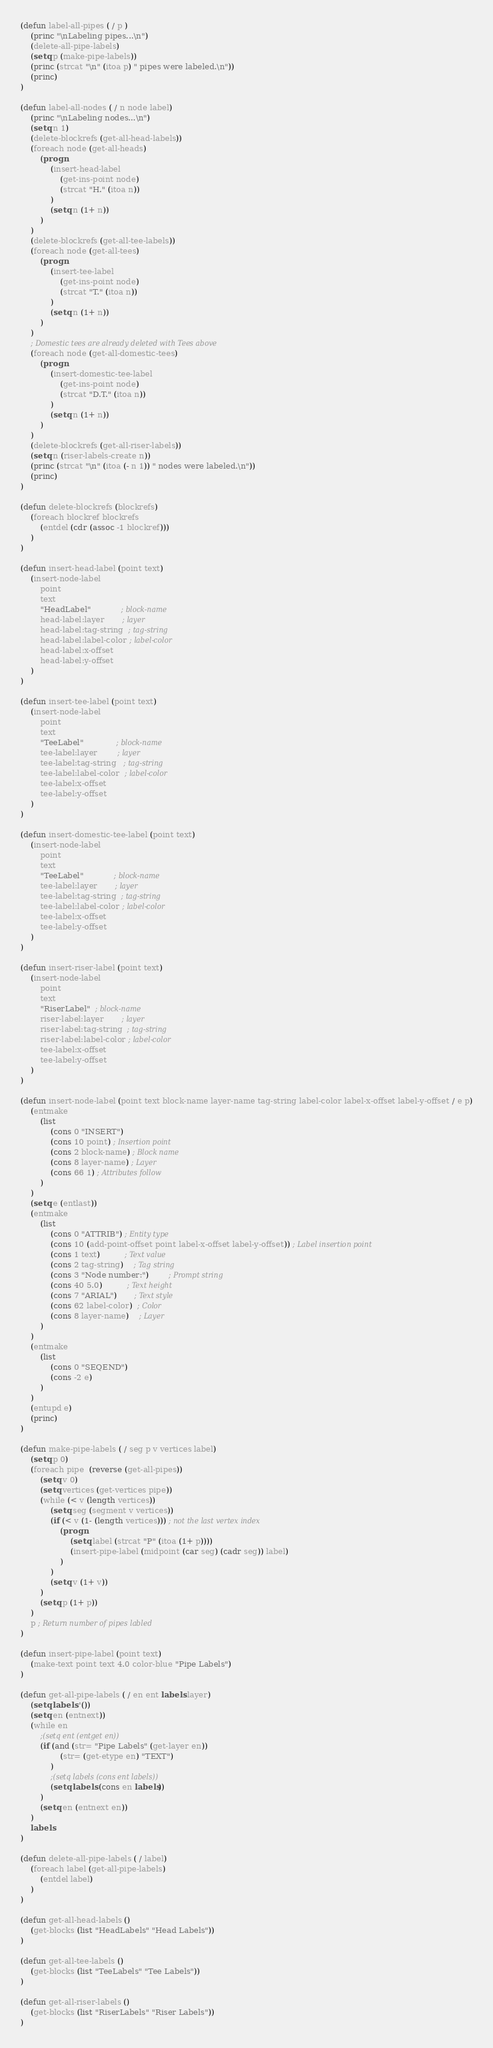<code> <loc_0><loc_0><loc_500><loc_500><_Lisp_>(defun label-all-pipes ( / p )
    (princ "\nLabeling pipes...\n")
    (delete-all-pipe-labels)
    (setq p (make-pipe-labels))
    (princ (strcat "\n" (itoa p) " pipes were labeled.\n"))
    (princ)
)

(defun label-all-nodes ( / n node label)
    (princ "\nLabeling nodes...\n")
    (setq n 1)
    (delete-blockrefs (get-all-head-labels))
    (foreach node (get-all-heads)
        (progn    
            (insert-head-label 
                (get-ins-point node) 
                (strcat "H." (itoa n))
            )
            (setq n (1+ n))
        )
    )
    (delete-blockrefs (get-all-tee-labels))
    (foreach node (get-all-tees)
        (progn        
            (insert-tee-label 
                (get-ins-point node) 
                (strcat "T." (itoa n))
            )
            (setq n (1+ n))
        )
    )
    ; Domestic tees are already deleted with Tees above
    (foreach node (get-all-domestic-tees)
        (progn        
            (insert-domestic-tee-label 
                (get-ins-point node) 
                (strcat "D.T." (itoa n))
            )
            (setq n (1+ n))
        )
    )
    (delete-blockrefs (get-all-riser-labels)) 
    (setq n (riser-labels-create n))
    (princ (strcat "\n" (itoa (- n 1)) " nodes were labeled.\n"))
    (princ)
)

(defun delete-blockrefs (blockrefs)
    (foreach blockref blockrefs
        (entdel (cdr (assoc -1 blockref)))
    )
)

(defun insert-head-label (point text)
    (insert-node-label 
        point 
        text 
        "HeadLabel"            ; block-name
        head-label:layer       ; layer
        head-label:tag-string  ; tag-string
        head-label:label-color ; label-color
        head-label:x-offset
        head-label:y-offset
    )
)

(defun insert-tee-label (point text)
    (insert-node-label 
        point 
        text 
        "TeeLabel"             ; block-name
        tee-label:layer        ; layer
        tee-label:tag-string   ; tag-string
        tee-label:label-color  ; label-color
        tee-label:x-offset
        tee-label:y-offset
    )
)

(defun insert-domestic-tee-label (point text)
    (insert-node-label 
        point 
        text 
        "TeeLabel"            ; block-name
        tee-label:layer       ; layer
        tee-label:tag-string  ; tag-string
        tee-label:label-color ; label-color
        tee-label:x-offset
        tee-label:y-offset
    )
)

(defun insert-riser-label (point text)
    (insert-node-label 
        point 
        text 
        "RiserLabel"  ; block-name
        riser-label:layer       ; layer
        riser-label:tag-string  ; tag-string
        riser-label:label-color ; label-color
        tee-label:x-offset
        tee-label:y-offset
    )
)

(defun insert-node-label (point text block-name layer-name tag-string label-color label-x-offset label-y-offset / e p)
    (entmake
        (list 
            (cons 0 "INSERT")
            (cons 10 point) ; Insertion point
            (cons 2 block-name) ; Block name
            (cons 8 layer-name) ; Layer
            (cons 66 1) ; Attributes follow
        )
    )
    (setq e (entlast))
    (entmake
        (list 
            (cons 0 "ATTRIB") ; Entity type
            (cons 10 (add-point-offset point label-x-offset label-y-offset)) ; Label insertion point
            (cons 1 text)          ; Text value
            (cons 2 tag-string)    ; Tag string
            (cons 3 "Node number:")        ; Prompt string
            (cons 40 5.0)          ; Text height
            (cons 7 "ARIAL")       ; Text style
            (cons 62 label-color)  ; Color
            (cons 8 layer-name)    ; Layer
        )
    )
    (entmake
        (list 
            (cons 0 "SEQEND") 
            (cons -2 e)
        )
    )
    (entupd e)
    (princ)
)

(defun make-pipe-labels ( / seg p v vertices label)    
    (setq p 0)    
    (foreach pipe  (reverse (get-all-pipes))
        (setq v 0)                
        (setq vertices (get-vertices pipe))
        (while (< v (length vertices))
            (setq seg (segment v vertices))
            (if (< v (1- (length vertices))) ; not the last vertex index
                (progn
                    (setq label (strcat "P" (itoa (1+ p))))
                    (insert-pipe-label (midpoint (car seg) (cadr seg)) label)
                )
            )
            (setq v (1+ v))
        )
        (setq p (1+ p))
    )
    p ; Return number of pipes labled
)

(defun insert-pipe-label (point text)
    (make-text point text 4.0 color-blue "Pipe Labels")
)

(defun get-all-pipe-labels ( / en ent labels layer) 
    (setq labels '())
    (setq en (entnext))
    (while en
        ;(setq ent (entget en))
        (if (and (str= "Pipe Labels" (get-layer en))
                (str= (get-etype en) "TEXT")
            )
            ;(setq labels (cons ent labels))
            (setq labels (cons en labels))
        )
        (setq en (entnext en))
    )
    labels
)

(defun delete-all-pipe-labels ( / label)
    (foreach label (get-all-pipe-labels)
        (entdel label)
    )
)

(defun get-all-head-labels ()
    (get-blocks (list "HeadLabels" "Head Labels"))
)

(defun get-all-tee-labels ()
    (get-blocks (list "TeeLabels" "Tee Labels"))
)

(defun get-all-riser-labels ()
    (get-blocks (list "RiserLabels" "Riser Labels"))
)
</code> 